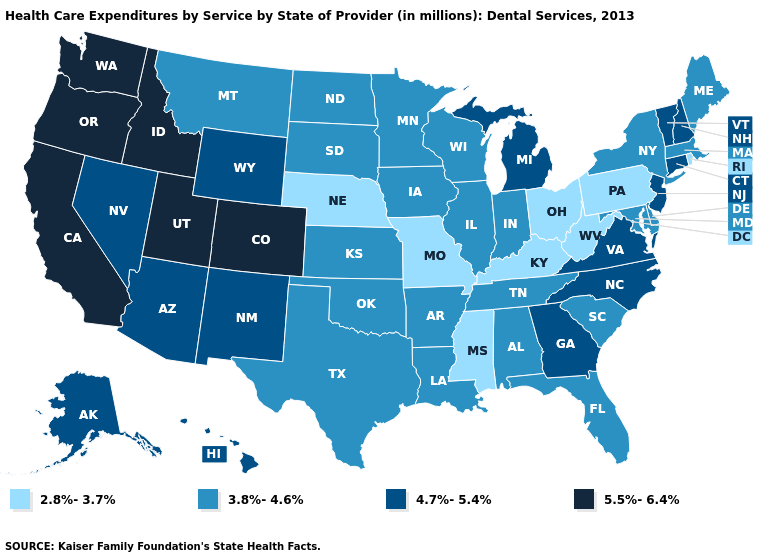What is the value of Utah?
Give a very brief answer. 5.5%-6.4%. Name the states that have a value in the range 4.7%-5.4%?
Quick response, please. Alaska, Arizona, Connecticut, Georgia, Hawaii, Michigan, Nevada, New Hampshire, New Jersey, New Mexico, North Carolina, Vermont, Virginia, Wyoming. Among the states that border Oregon , does Nevada have the lowest value?
Answer briefly. Yes. Among the states that border Michigan , which have the highest value?
Give a very brief answer. Indiana, Wisconsin. Does Kentucky have the lowest value in the USA?
Write a very short answer. Yes. What is the lowest value in the West?
Quick response, please. 3.8%-4.6%. Name the states that have a value in the range 5.5%-6.4%?
Short answer required. California, Colorado, Idaho, Oregon, Utah, Washington. Name the states that have a value in the range 5.5%-6.4%?
Write a very short answer. California, Colorado, Idaho, Oregon, Utah, Washington. Does Wyoming have a lower value than Connecticut?
Give a very brief answer. No. Name the states that have a value in the range 3.8%-4.6%?
Be succinct. Alabama, Arkansas, Delaware, Florida, Illinois, Indiana, Iowa, Kansas, Louisiana, Maine, Maryland, Massachusetts, Minnesota, Montana, New York, North Dakota, Oklahoma, South Carolina, South Dakota, Tennessee, Texas, Wisconsin. Does the first symbol in the legend represent the smallest category?
Quick response, please. Yes. Does South Carolina have the same value as West Virginia?
Give a very brief answer. No. Name the states that have a value in the range 3.8%-4.6%?
Answer briefly. Alabama, Arkansas, Delaware, Florida, Illinois, Indiana, Iowa, Kansas, Louisiana, Maine, Maryland, Massachusetts, Minnesota, Montana, New York, North Dakota, Oklahoma, South Carolina, South Dakota, Tennessee, Texas, Wisconsin. Among the states that border Louisiana , does Mississippi have the lowest value?
Be succinct. Yes. Is the legend a continuous bar?
Answer briefly. No. 